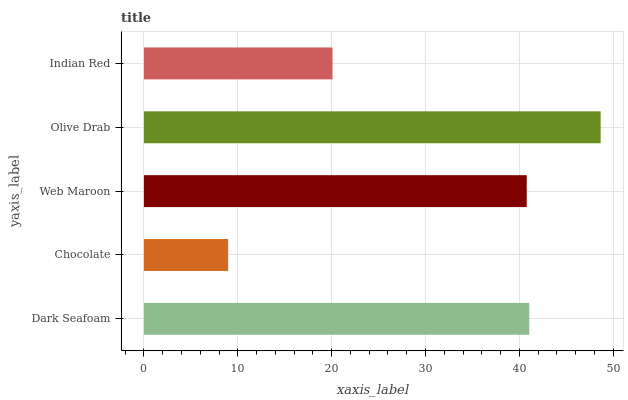Is Chocolate the minimum?
Answer yes or no. Yes. Is Olive Drab the maximum?
Answer yes or no. Yes. Is Web Maroon the minimum?
Answer yes or no. No. Is Web Maroon the maximum?
Answer yes or no. No. Is Web Maroon greater than Chocolate?
Answer yes or no. Yes. Is Chocolate less than Web Maroon?
Answer yes or no. Yes. Is Chocolate greater than Web Maroon?
Answer yes or no. No. Is Web Maroon less than Chocolate?
Answer yes or no. No. Is Web Maroon the high median?
Answer yes or no. Yes. Is Web Maroon the low median?
Answer yes or no. Yes. Is Dark Seafoam the high median?
Answer yes or no. No. Is Chocolate the low median?
Answer yes or no. No. 